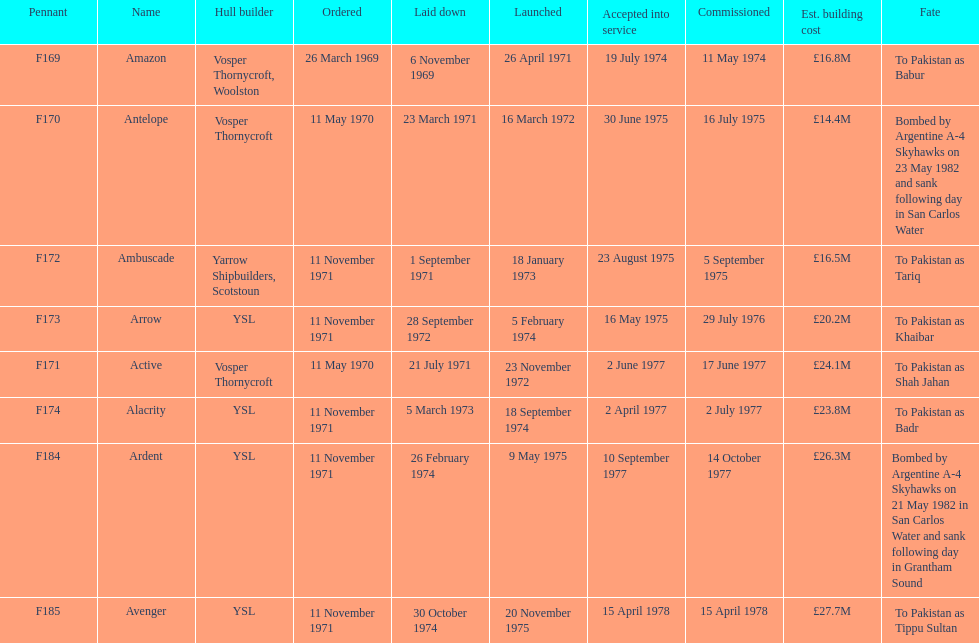What is the last name listed on this chart? Avenger. 